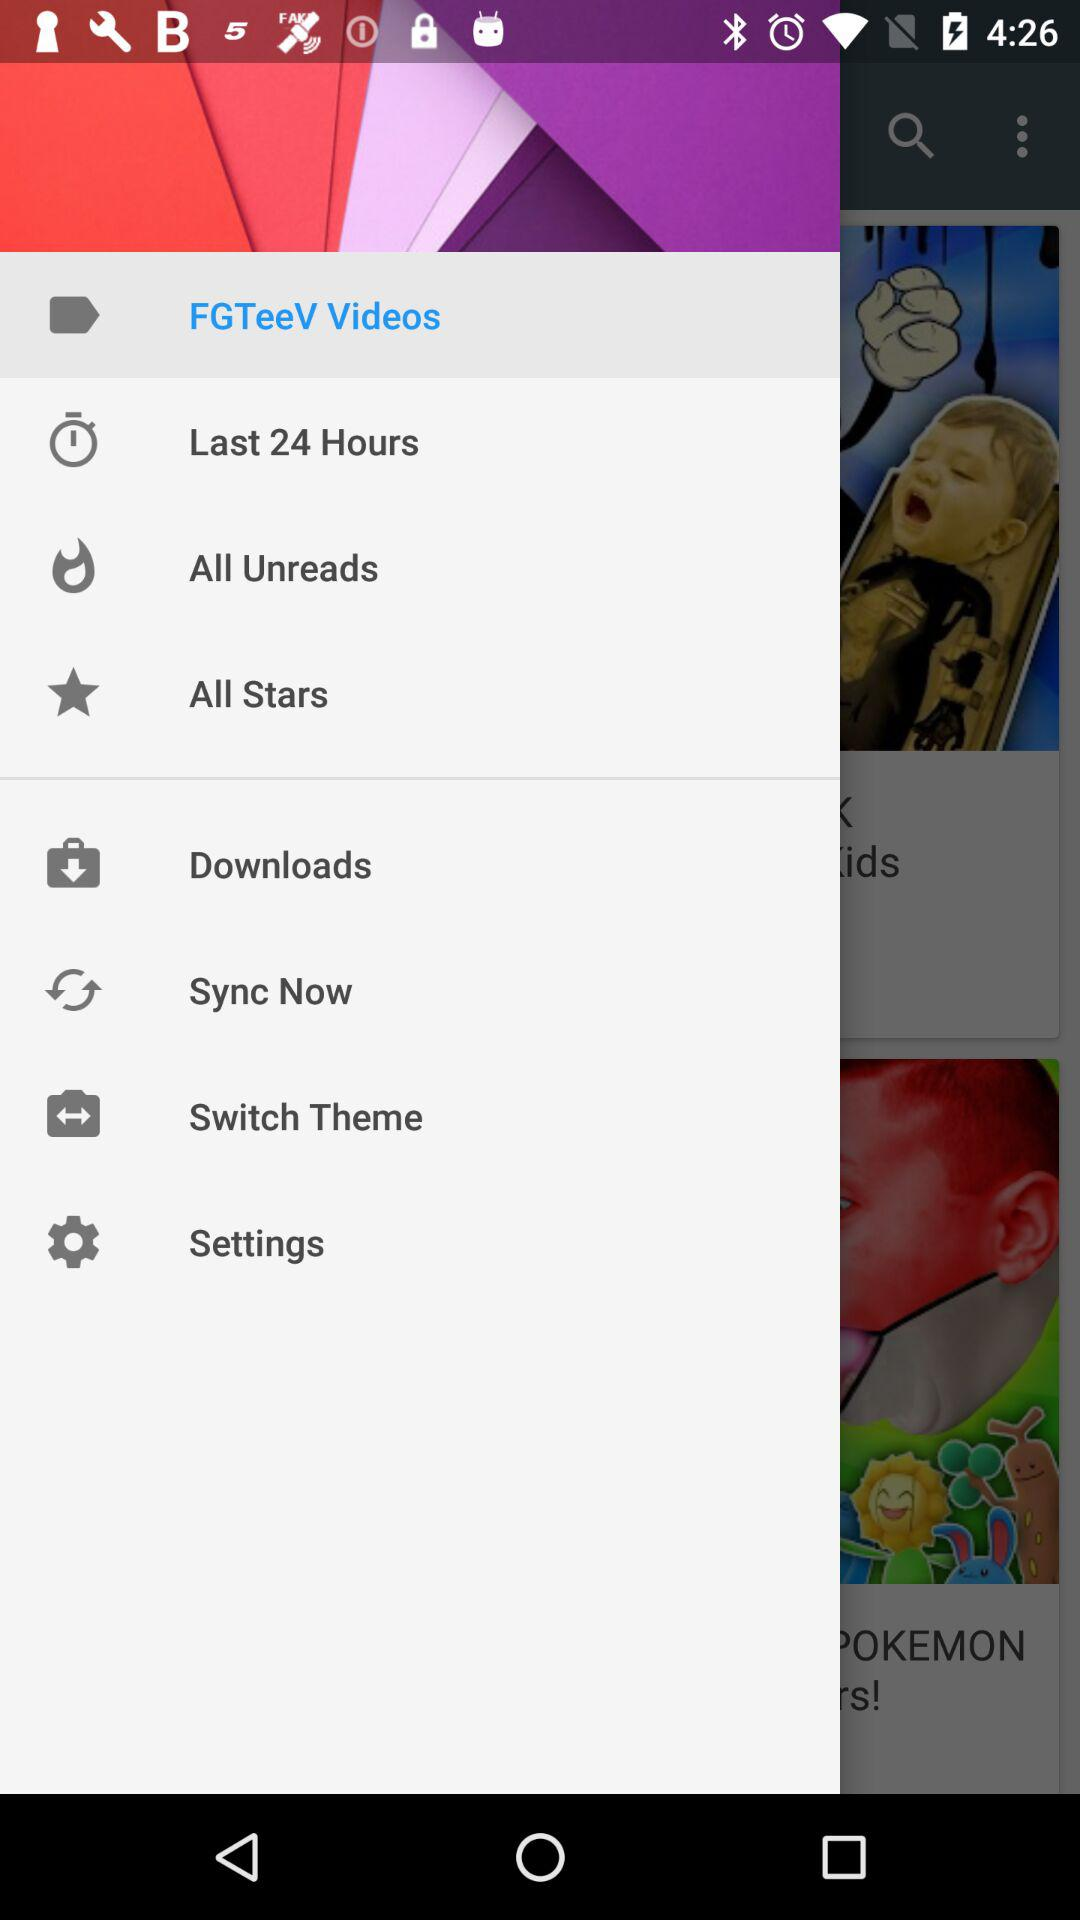What option is selected? The selected option is FGTeeV Videos. 